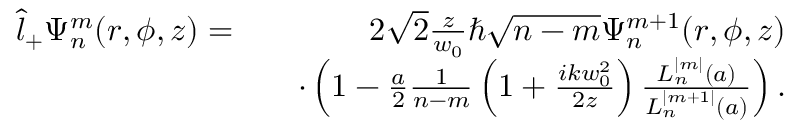<formula> <loc_0><loc_0><loc_500><loc_500>\begin{array} { r l r } { \hat { l } _ { + } \Psi _ { n } ^ { m } ( r , \phi , z ) = } & { 2 \sqrt { 2 } \frac { z } { w _ { 0 } } \hbar { \sqrt } { n - m } \Psi _ { n } ^ { m + 1 } ( r , \phi , z ) } \\ & { \cdot \left ( 1 - \frac { a } { 2 } \frac { 1 } { n - m } \left ( 1 + \frac { i k w _ { 0 } ^ { 2 } } { 2 z } \right ) \frac { L _ { n } ^ { | m | } ( a ) } { L _ { n } ^ { | m + 1 | } ( a ) } \right ) . } \end{array}</formula> 